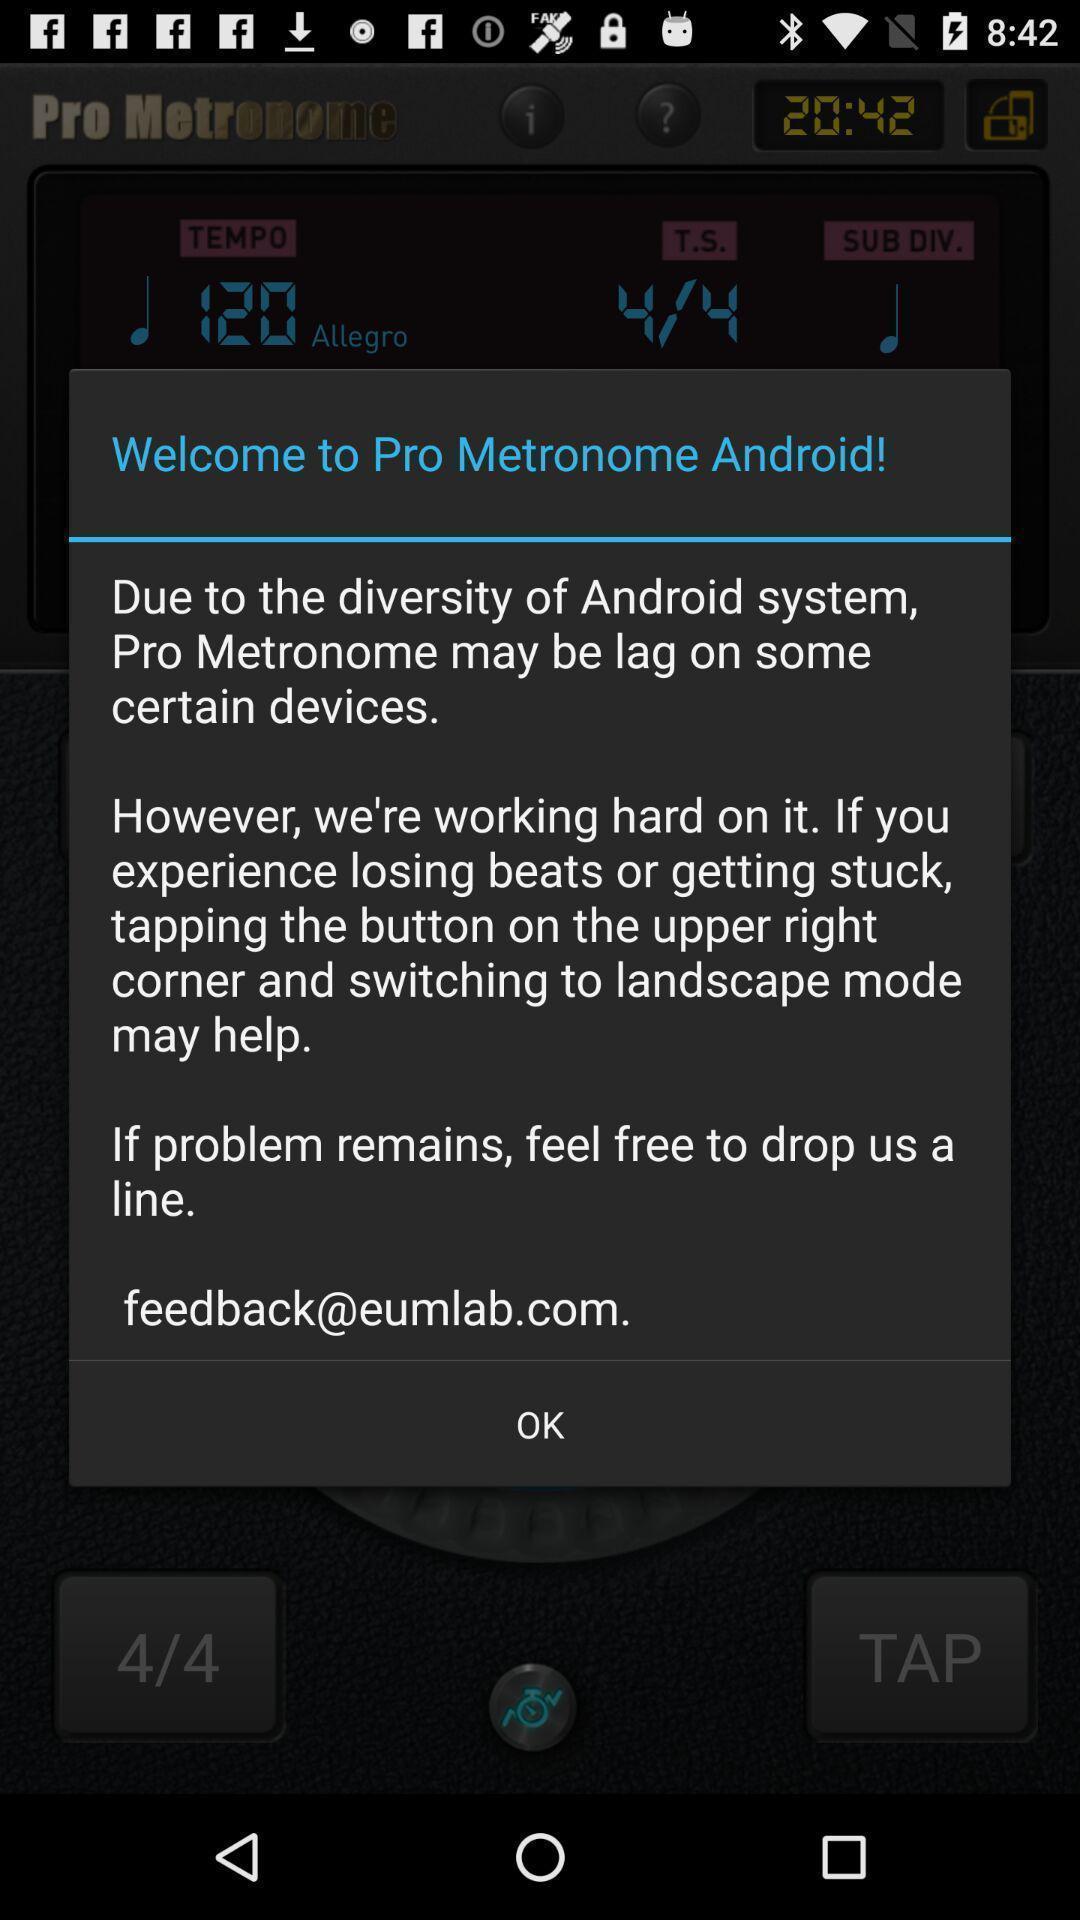Provide a detailed account of this screenshot. Welcome page. 